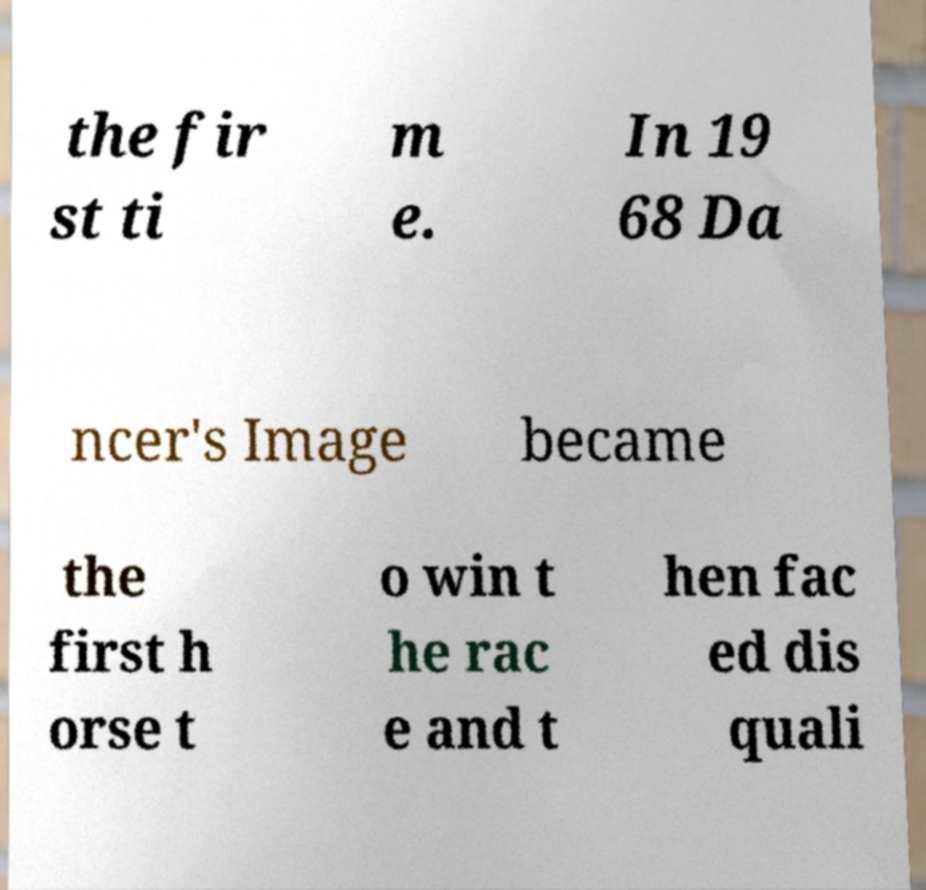Could you assist in decoding the text presented in this image and type it out clearly? the fir st ti m e. In 19 68 Da ncer's Image became the first h orse t o win t he rac e and t hen fac ed dis quali 